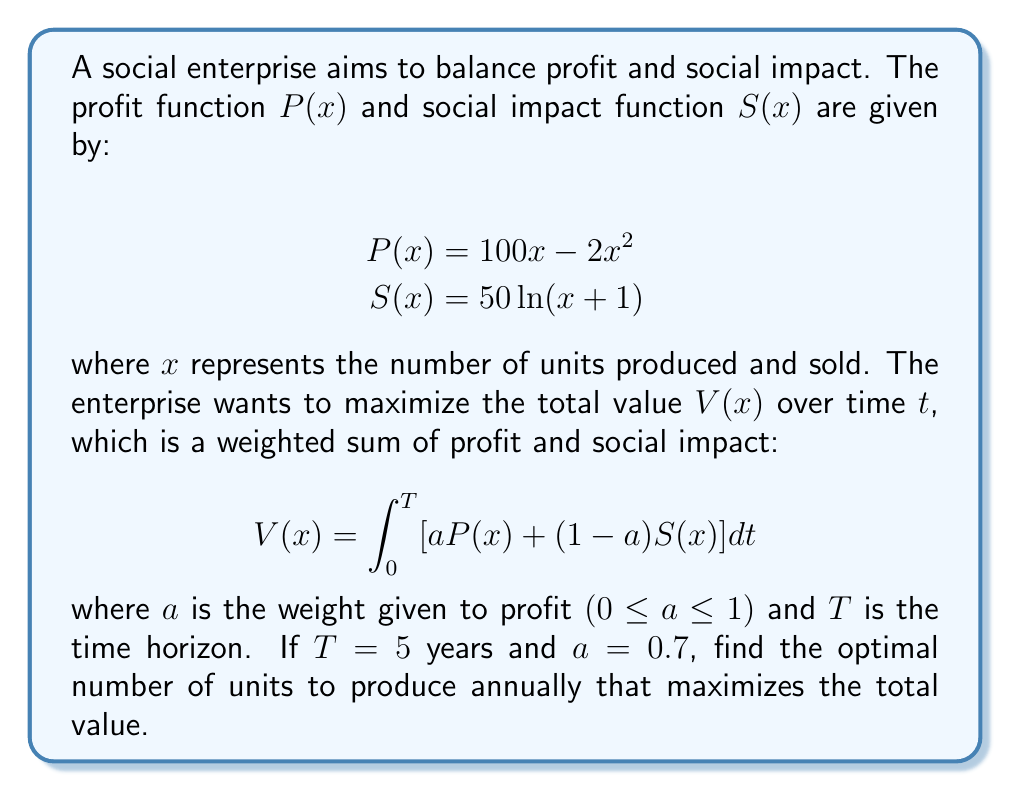Give your solution to this math problem. Let's approach this step-by-step:

1) First, we need to set up the integral equation for the total value:

   $$V(x) = \int_0^5 [0.7(100x - 2x^2) + 0.3(50\ln(x+1))] dt$$

2) Since $x$ is not a function of $t$, we can simplify this to:

   $$V(x) = 5[0.7(100x - 2x^2) + 0.3(50\ln(x+1))]$$

3) To find the maximum value, we need to differentiate $V(x)$ with respect to $x$ and set it to zero:

   $$\frac{dV}{dx} = 5[0.7(100 - 4x) + 0.3(\frac{50}{x+1})] = 0$$

4) Simplifying:

   $$70(100 - 4x) + 15(\frac{50}{x+1}) = 0$$

5) Multiplying both sides by $(x+1)$:

   $$70(100 - 4x)(x+1) + 750 = 0$$

6) Expanding:

   $$7000x + 7000 - 280x^2 - 280x + 750 = 0$$
   $$280x^2 - 6720x - 7750 = 0$$

7) This is a quadratic equation. We can solve it using the quadratic formula:

   $$x = \frac{-b \pm \sqrt{b^2 - 4ac}}{2a}$$

   where $a = 280$, $b = -6720$, and $c = -7750$

8) Plugging in these values:

   $$x = \frac{6720 \pm \sqrt{(-6720)^2 - 4(280)(-7750)}}{2(280)}$$

9) Solving this:

   $$x \approx 25.11 \text{ or } -1.11$$

10) Since $x$ represents the number of units, it must be positive. Therefore, the optimal number of units to produce annually is approximately 25.11.
Answer: 25.11 units 